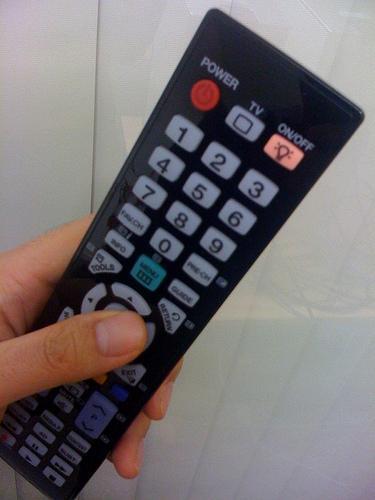How many remotes are in the photo?
Give a very brief answer. 1. 